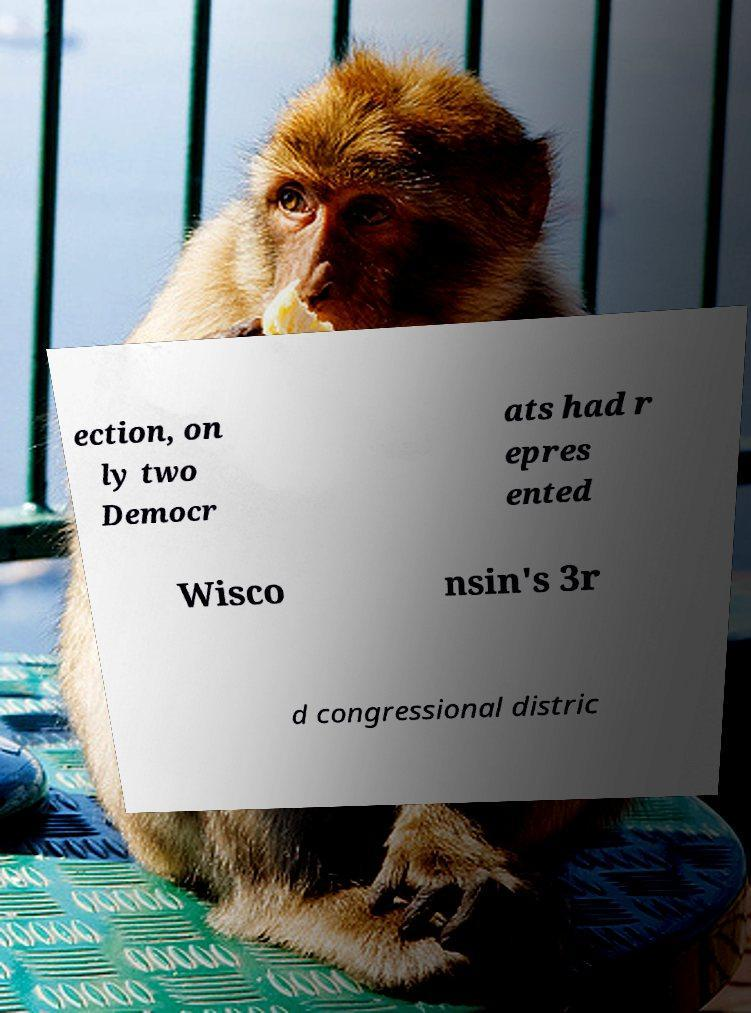Can you read and provide the text displayed in the image?This photo seems to have some interesting text. Can you extract and type it out for me? ection, on ly two Democr ats had r epres ented Wisco nsin's 3r d congressional distric 